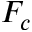<formula> <loc_0><loc_0><loc_500><loc_500>F _ { c }</formula> 